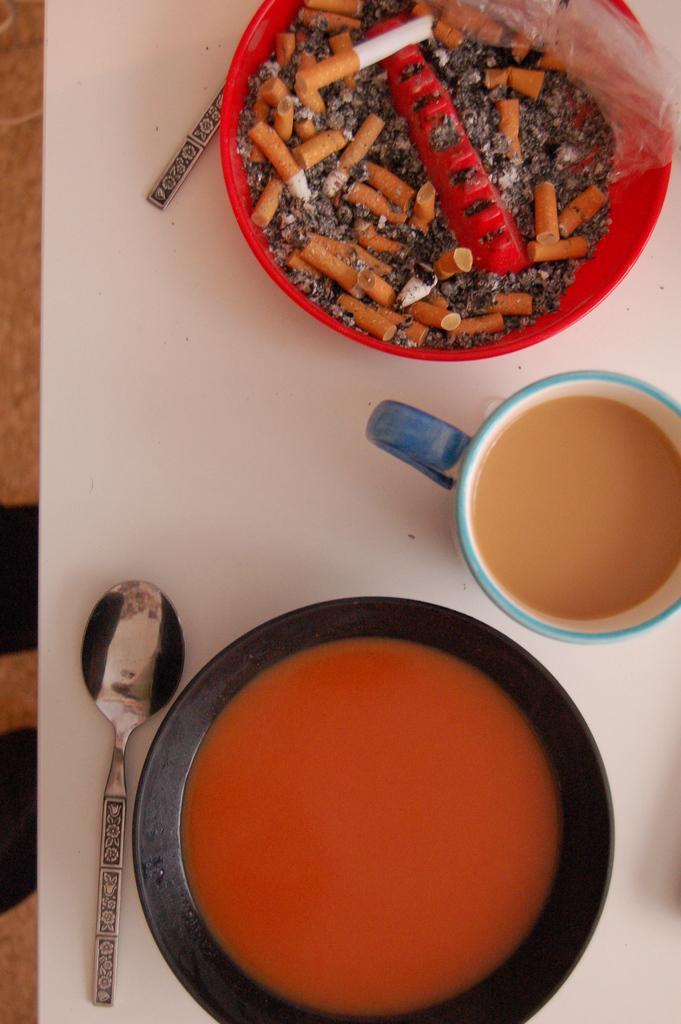How would you summarize this image in a sentence or two? This is a top view of an image where we can see a bowl with soup, spoons, a cup with a drink in it and a bowl with cigarette ashes, which are kept on the white color table. 